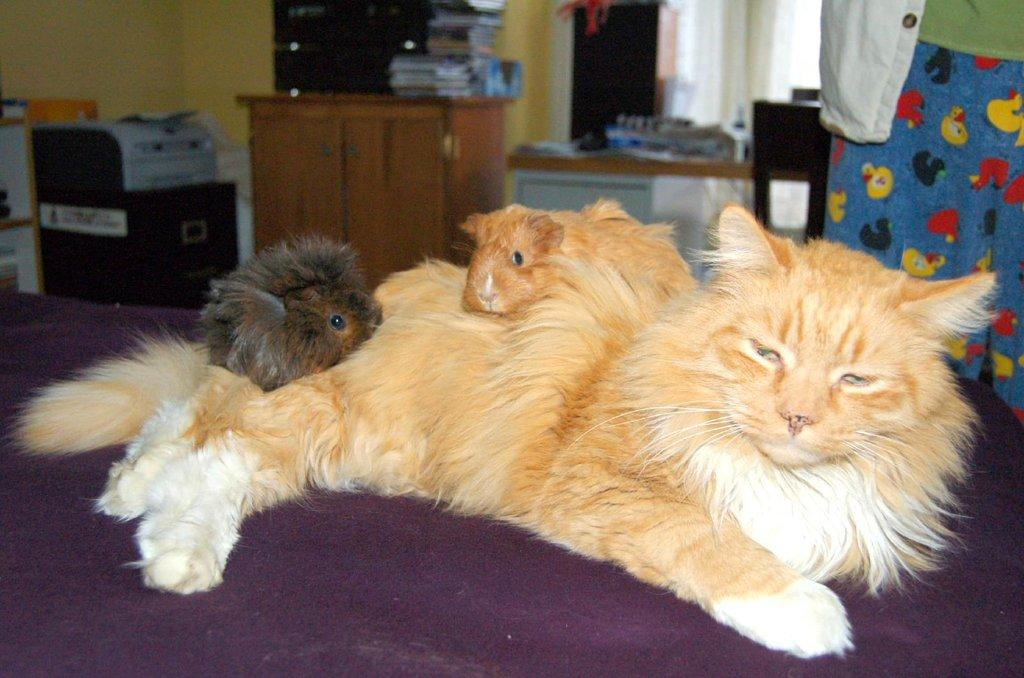What are the animals lying on in the image? The animals are lying on a cot in the image. What can be seen in the background of the image? There is a television set, books on a cabinet, a printer, persons standing, curtains, and walls in the background. What type of hat is the animal wearing in the image? There are no animals wearing hats in the image. What activity are the animals participating in while lying on the cot? The image does not show the animals participating in any specific activity; they are simply lying on the cot. 